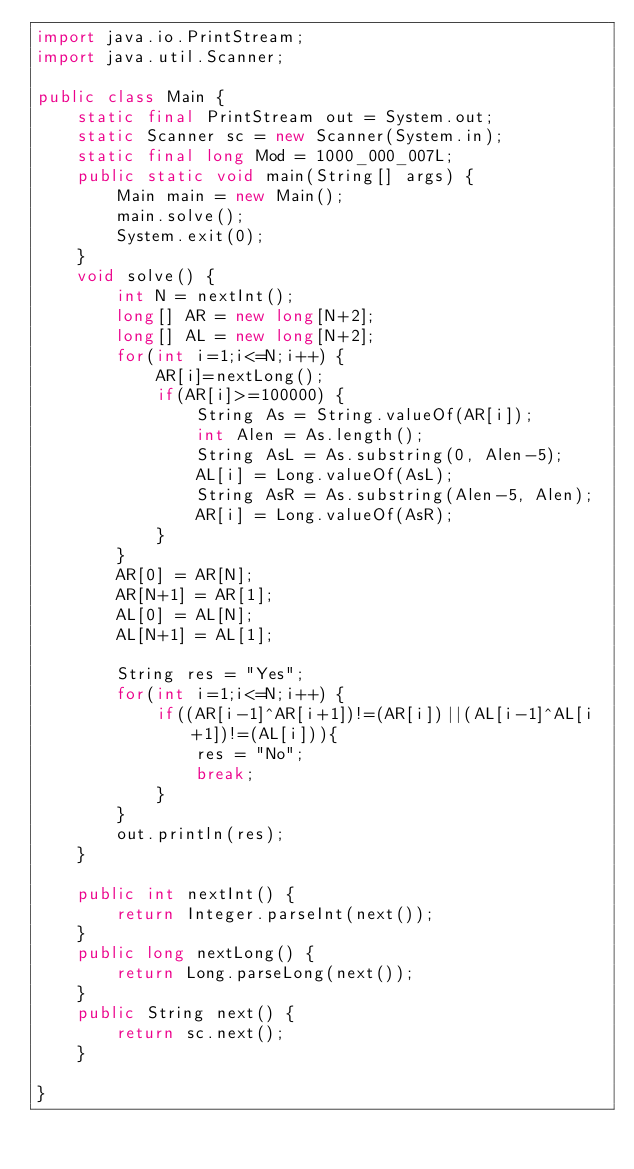Convert code to text. <code><loc_0><loc_0><loc_500><loc_500><_Java_>import java.io.PrintStream;
import java.util.Scanner;

public class Main {
	static final PrintStream out = System.out;
	static Scanner sc = new Scanner(System.in);
	static final long Mod = 1000_000_007L;
	public static void main(String[] args) {
		Main main = new Main();
		main.solve();
		System.exit(0);
	}
	void solve() {
		int N = nextInt();
		long[] AR = new long[N+2];
		long[] AL = new long[N+2];
		for(int i=1;i<=N;i++) {
			AR[i]=nextLong();
			if(AR[i]>=100000) {
				String As = String.valueOf(AR[i]);
				int Alen = As.length();
				String AsL = As.substring(0, Alen-5);
				AL[i] = Long.valueOf(AsL);
				String AsR = As.substring(Alen-5, Alen);
				AR[i] = Long.valueOf(AsR);
			}
		}
		AR[0] = AR[N];
		AR[N+1] = AR[1];
		AL[0] = AL[N];
		AL[N+1] = AL[1];

		String res = "Yes";
		for(int i=1;i<=N;i++) {
			if((AR[i-1]^AR[i+1])!=(AR[i])||(AL[i-1]^AL[i+1])!=(AL[i])){
				res = "No";
				break;
			}
		}
		out.println(res);
	}
	
	public int nextInt() {
		return Integer.parseInt(next());
	}
	public long nextLong() {
		return Long.parseLong(next());
	}
	public String next() {
		return sc.next();
	}

}</code> 